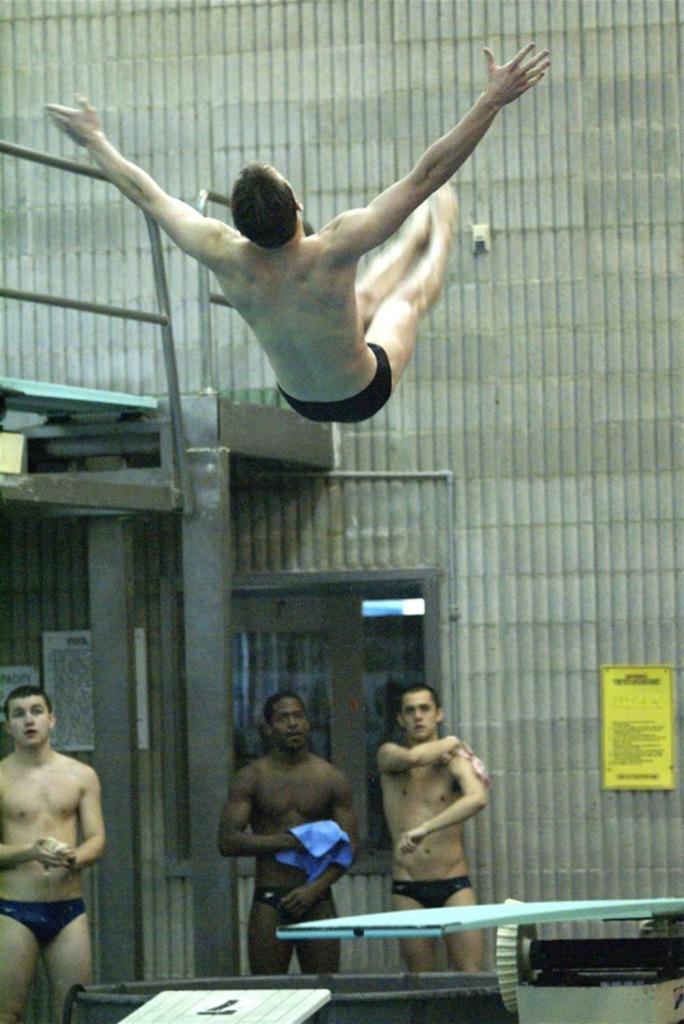In one or two sentences, can you explain what this image depicts? In the picture we can see some people are standing near the swimming pool without clothes and one person is in air jumping and behind them we can see a wall and near to it we can see poles and top of it we can see a path with railing to it. 